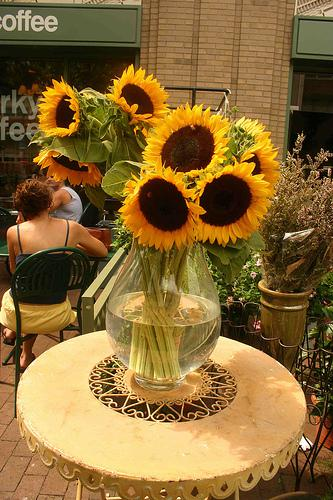Question: what kind of flower is depicted?
Choices:
A. Daisies.
B. Sunflowers.
C. Roses.
D. Tulips.
Answer with the letter. Answer: B Question: what color is the center of the flowers?
Choices:
A. Red.
B. Brown.
C. Yellow.
D. Orange.
Answer with the letter. Answer: B Question: how many women are pictured?
Choices:
A. 3.
B. 4.
C. 5.
D. 2.
Answer with the letter. Answer: D Question: what are the flowers sitting in?
Choices:
A. A pot.
B. A vase.
C. A coffee can.
D. A box.
Answer with the letter. Answer: B Question: what is the vase made of?
Choices:
A. Glass.
B. Plastic.
C. Metal.
D. Wood.
Answer with the letter. Answer: A 